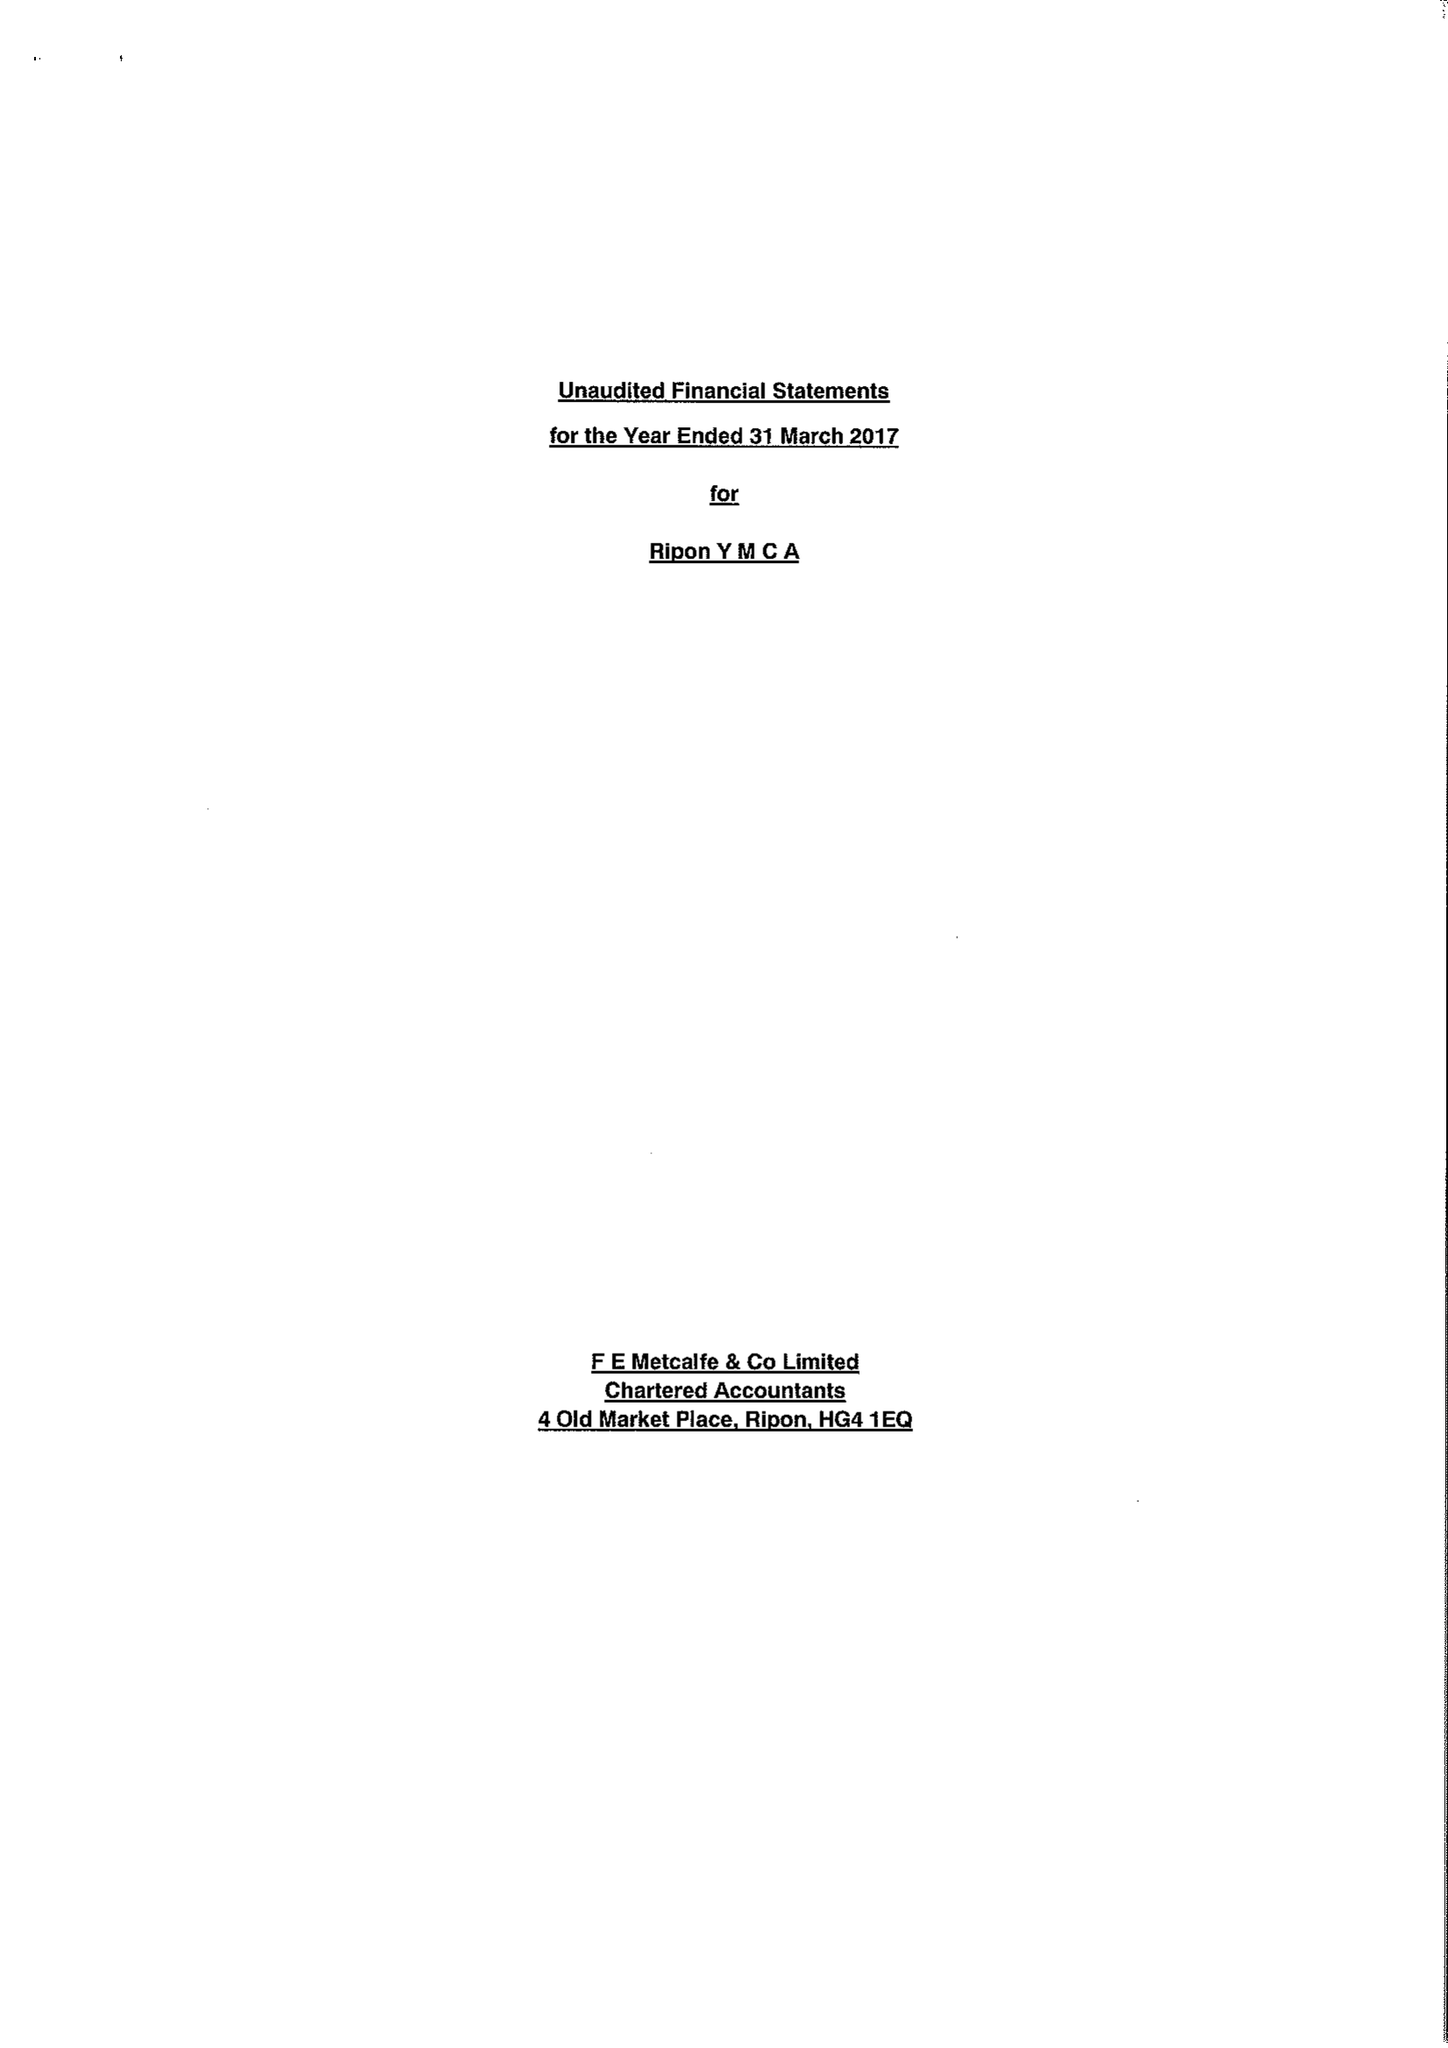What is the value for the address__postcode?
Answer the question using a single word or phrase. HG4 1BQ 